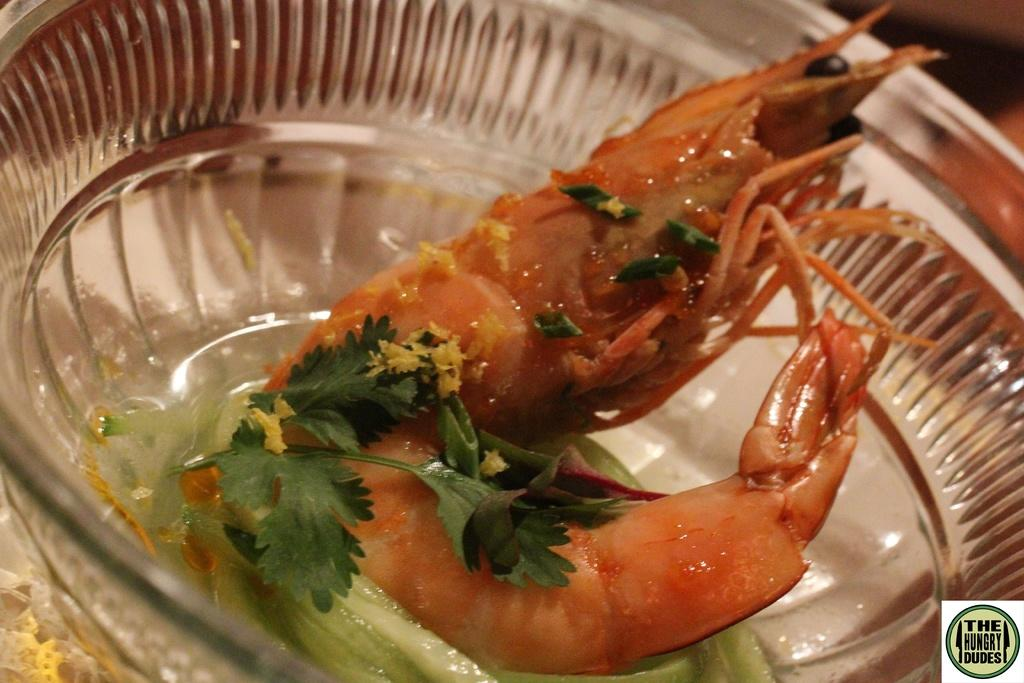What type of container is holding the food item in the image? There is a food item in a glass bowl in the image. Can you describe any additional features of the image? There is a watermark in the bottom right side of the image. What type of transport is visible in the image? There is no transport visible in the image. Which direction is the van heading in the image? There is no van present in the image. 